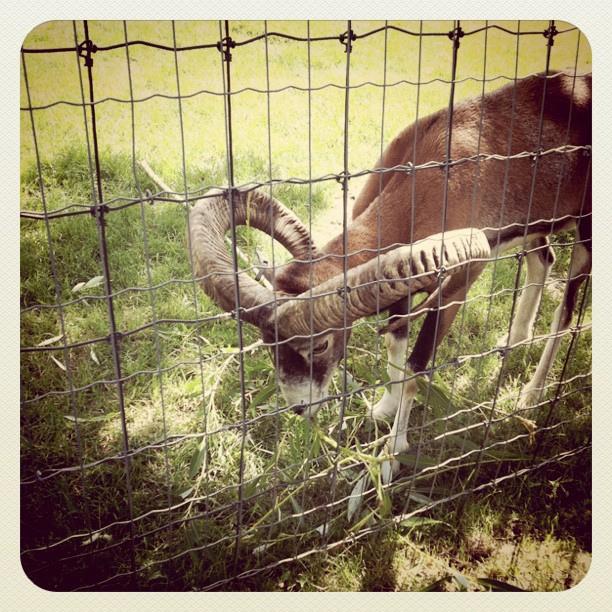What is keeping the animal from wandering off?
Answer briefly. Fence. Are these horns too big for this animal?
Give a very brief answer. Yes. IS the animal in a fence?
Short answer required. Yes. 